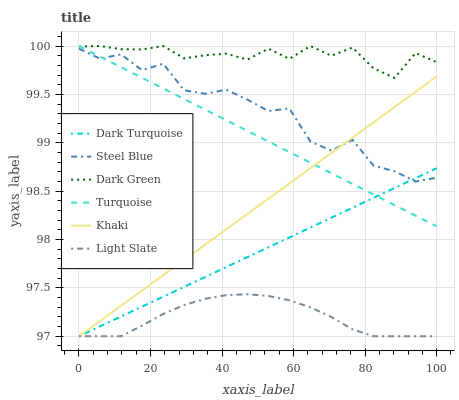Does Light Slate have the minimum area under the curve?
Answer yes or no. Yes. Does Dark Green have the maximum area under the curve?
Answer yes or no. Yes. Does Khaki have the minimum area under the curve?
Answer yes or no. No. Does Khaki have the maximum area under the curve?
Answer yes or no. No. Is Khaki the smoothest?
Answer yes or no. Yes. Is Steel Blue the roughest?
Answer yes or no. Yes. Is Light Slate the smoothest?
Answer yes or no. No. Is Light Slate the roughest?
Answer yes or no. No. Does Khaki have the lowest value?
Answer yes or no. Yes. Does Steel Blue have the lowest value?
Answer yes or no. No. Does Dark Green have the highest value?
Answer yes or no. Yes. Does Khaki have the highest value?
Answer yes or no. No. Is Steel Blue less than Dark Green?
Answer yes or no. Yes. Is Turquoise greater than Light Slate?
Answer yes or no. Yes. Does Dark Green intersect Turquoise?
Answer yes or no. Yes. Is Dark Green less than Turquoise?
Answer yes or no. No. Is Dark Green greater than Turquoise?
Answer yes or no. No. Does Steel Blue intersect Dark Green?
Answer yes or no. No. 